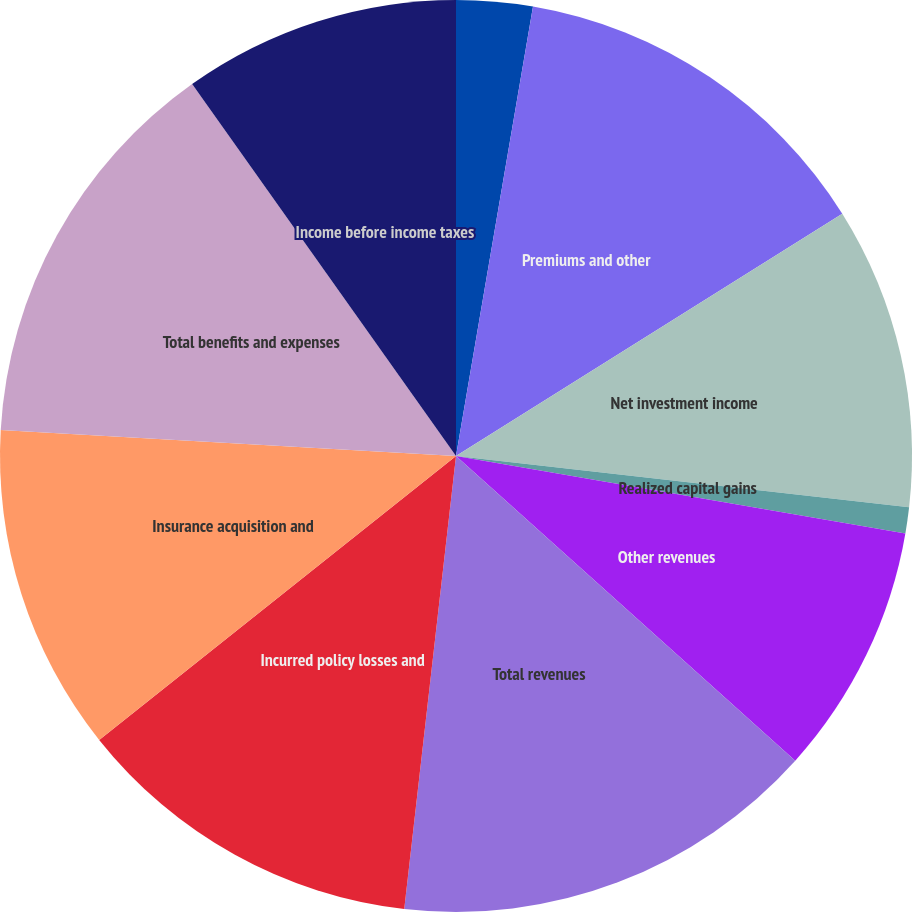Convert chart. <chart><loc_0><loc_0><loc_500><loc_500><pie_chart><fcel>Years Ended December 31 (in<fcel>Premiums and other<fcel>Net investment income<fcel>Realized capital gains<fcel>Other revenues<fcel>Total revenues<fcel>Incurred policy losses and<fcel>Insurance acquisition and<fcel>Total benefits and expenses<fcel>Income before income taxes<nl><fcel>2.7%<fcel>13.38%<fcel>10.71%<fcel>0.92%<fcel>8.93%<fcel>15.16%<fcel>12.49%<fcel>11.6%<fcel>14.27%<fcel>9.82%<nl></chart> 